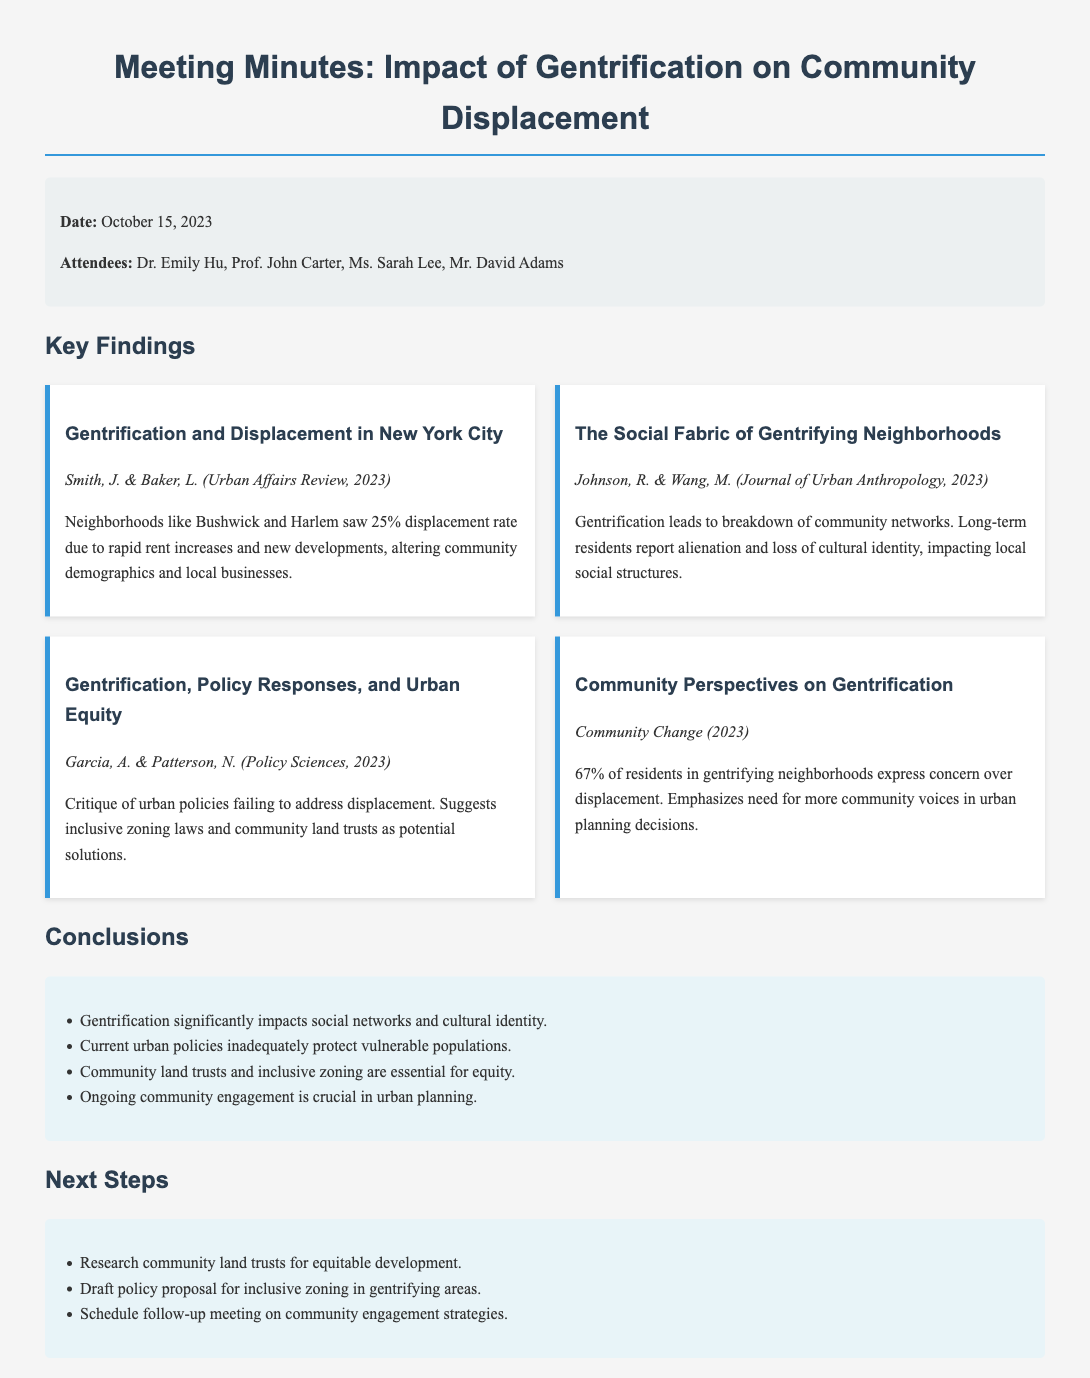What date was the meeting held? The date of the meeting is explicitly mentioned in the document, which is October 15, 2023.
Answer: October 15, 2023 Who were the attendees at the meeting? The attendees are listed under the meta-info section, detailing their names.
Answer: Dr. Emily Hu, Prof. John Carter, Ms. Sarah Lee, Mr. David Adams What is the displacement rate mentioned for neighborhoods like Bushwick and Harlem? The displacement rate is specified in the first key finding of the document.
Answer: 25% What percentage of residents in gentrifying neighborhoods express concern over displacement? This statistic is provided in the finding about community perspectives on gentrification.
Answer: 67% Which policy responses are suggested as potential solutions to address displacement? The suggested solutions are mentioned in the third key finding, summarizing the authors' critiques and proposals.
Answer: Inclusive zoning laws and community land trusts What is one of the key conclusions drawn from the analysis on gentrification? The conclusions list summarizes several key findings regarding the impact of gentrification and urban policies.
Answer: Gentrification significantly impacts social networks and cultural identity What is the first next step proposed in the document? The next steps are displayed in a list format at the end of the document.
Answer: Research community land trusts for equitable development 